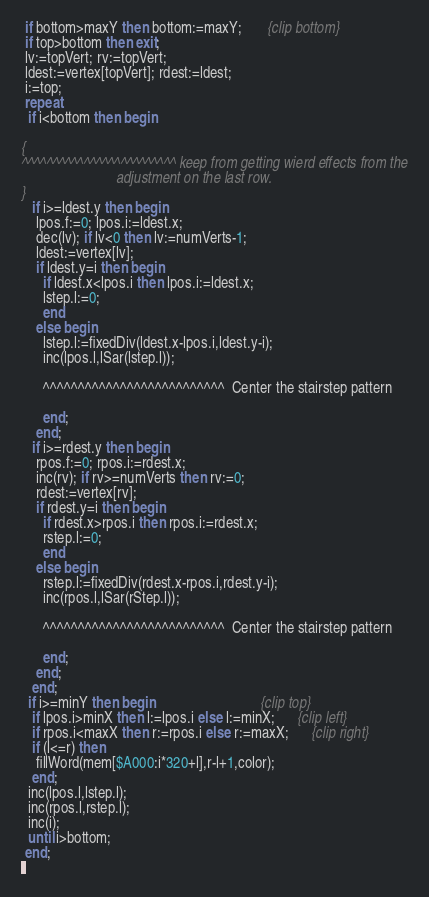<code> <loc_0><loc_0><loc_500><loc_500><_Pascal_> if bottom>maxY then bottom:=maxY;       {clip bottom}
 if top>bottom then exit;
 lv:=topVert; rv:=topVert;
 ldest:=vertex[topVert]; rdest:=ldest;
 i:=top;
 repeat
  if i<bottom then begin

{
^^^^^^^^^^^^^^^^^^^^^^^^^ keep from getting wierd effects from the
                          adjustment on the last row.
}
   if i>=ldest.y then begin
    lpos.f:=0; lpos.i:=ldest.x;
    dec(lv); if lv<0 then lv:=numVerts-1;
    ldest:=vertex[lv];
    if ldest.y=i then begin
      if ldest.x<lpos.i then lpos.i:=ldest.x;
      lstep.l:=0;
      end
    else begin
      lstep.l:=fixedDiv(ldest.x-lpos.i,ldest.y-i);
      inc(lpos.l,lSar(lstep.l));

      ^^^^^^^^^^^^^^^^^^^^^^^^^^  Center the stairstep pattern

      end;
    end;
   if i>=rdest.y then begin
    rpos.f:=0; rpos.i:=rdest.x;
    inc(rv); if rv>=numVerts then rv:=0;
    rdest:=vertex[rv];
    if rdest.y=i then begin
      if rdest.x>rpos.i then rpos.i:=rdest.x;
      rstep.l:=0;
      end
    else begin
      rstep.l:=fixedDiv(rdest.x-rpos.i,rdest.y-i);
      inc(rpos.l,lSar(rStep.l));

      ^^^^^^^^^^^^^^^^^^^^^^^^^^  Center the stairstep pattern

      end;
    end;
   end;
  if i>=minY then begin                             {clip top}
   if lpos.i>minX then l:=lpos.i else l:=minX;      {clip left}
   if rpos.i<maxX then r:=rpos.i else r:=maxX;      {clip right}
   if (l<=r) then
    fillWord(mem[$A000:i*320+l],r-l+1,color);
   end;
  inc(lpos.l,lstep.l);
  inc(rpos.l,rstep.l);
  inc(i);
  until i>bottom;
 end;
</code> 